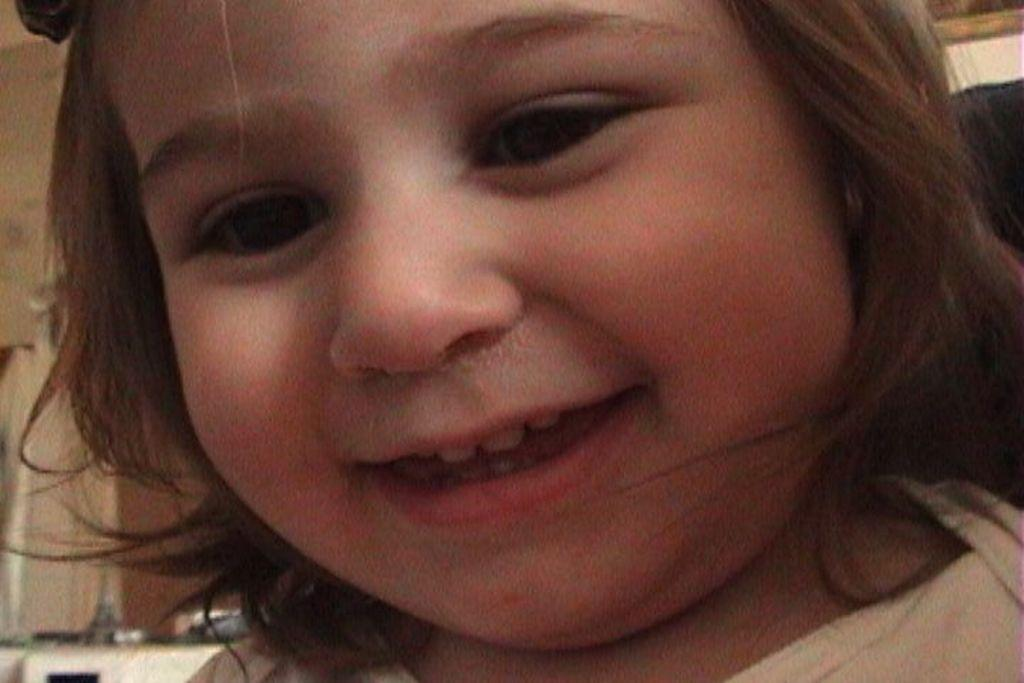Who is the main subject in the image? There is a girl in the image. What is the girl wearing? The girl is wearing a white dress. What expression does the girl have? The girl is smiling. What can be seen on the kitchen platform in the bottom left of the image? There are objects on a kitchen platform in the bottom left of the image. What type of bean is growing on the girl's head in the image? There is no bean growing on the girl's head in the image. 